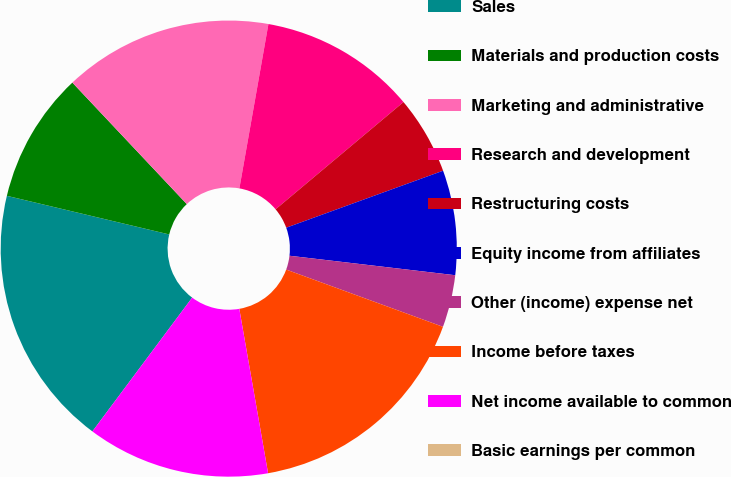Convert chart. <chart><loc_0><loc_0><loc_500><loc_500><pie_chart><fcel>Sales<fcel>Materials and production costs<fcel>Marketing and administrative<fcel>Research and development<fcel>Restructuring costs<fcel>Equity income from affiliates<fcel>Other (income) expense net<fcel>Income before taxes<fcel>Net income available to common<fcel>Basic earnings per common<nl><fcel>18.52%<fcel>9.26%<fcel>14.81%<fcel>11.11%<fcel>5.56%<fcel>7.41%<fcel>3.71%<fcel>16.67%<fcel>12.96%<fcel>0.0%<nl></chart> 